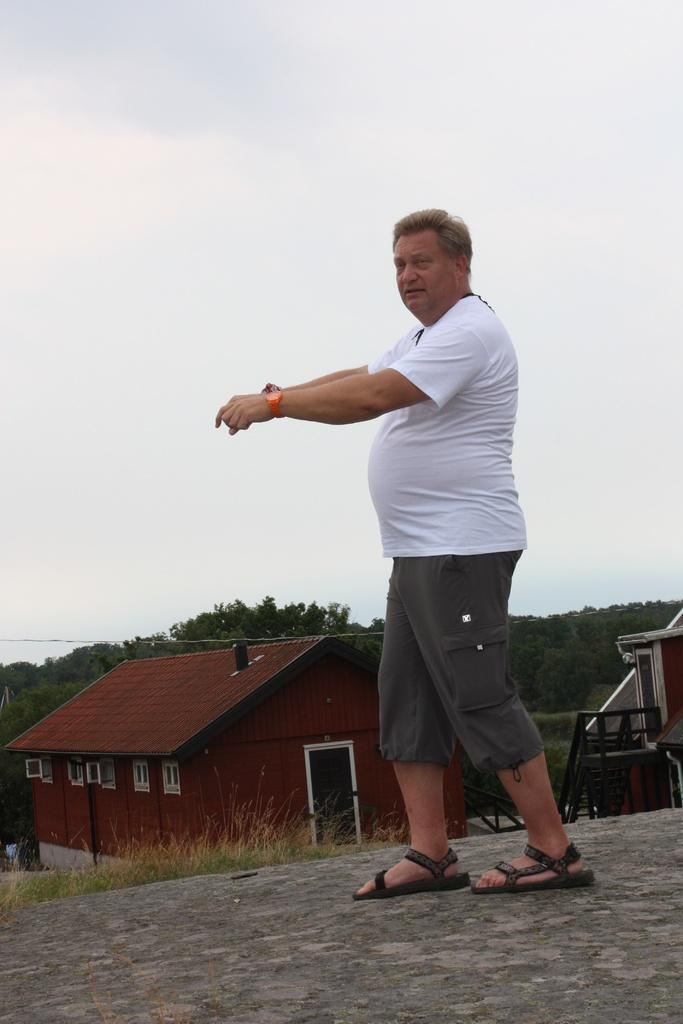What is the main subject of the image? There is a person standing in the image. What is the person standing on? The person is standing on the ground. What can be seen in the background of the image? There are houses, grass, trees, and the sky visible in the background of the image. What is the person's eye color in the image? The provided facts do not mention the person's eye color, so it cannot be determined from the image. 